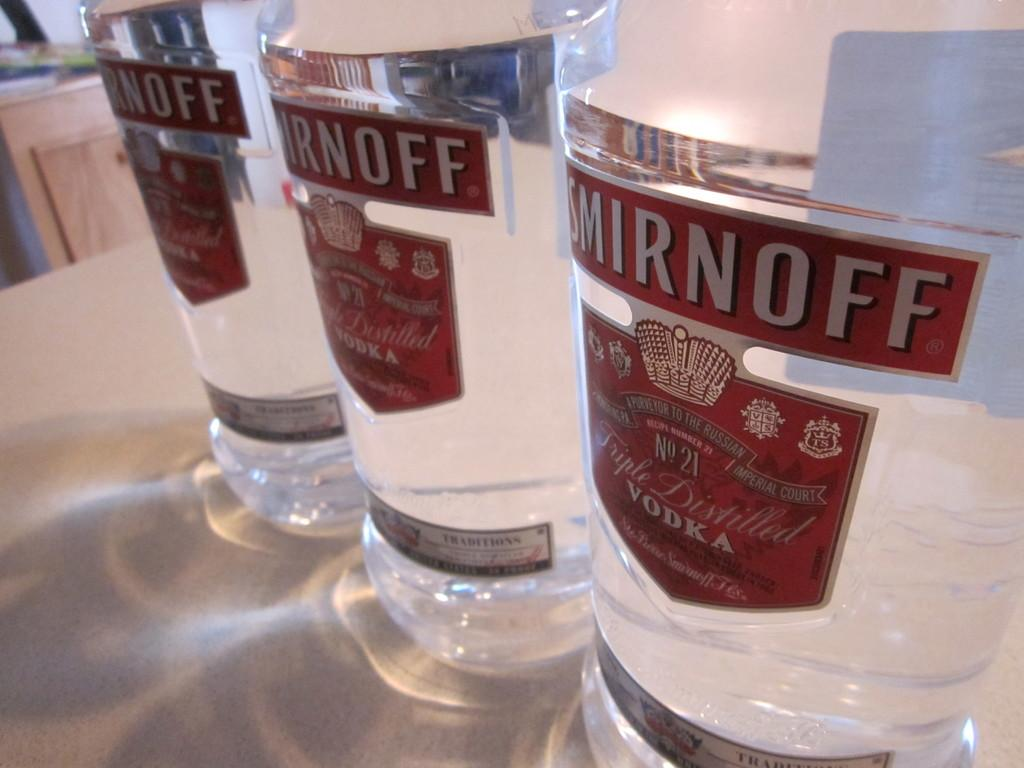<image>
Offer a succinct explanation of the picture presented. Three clear Smirnoff Vodka bottle with red labels atop a counter. 